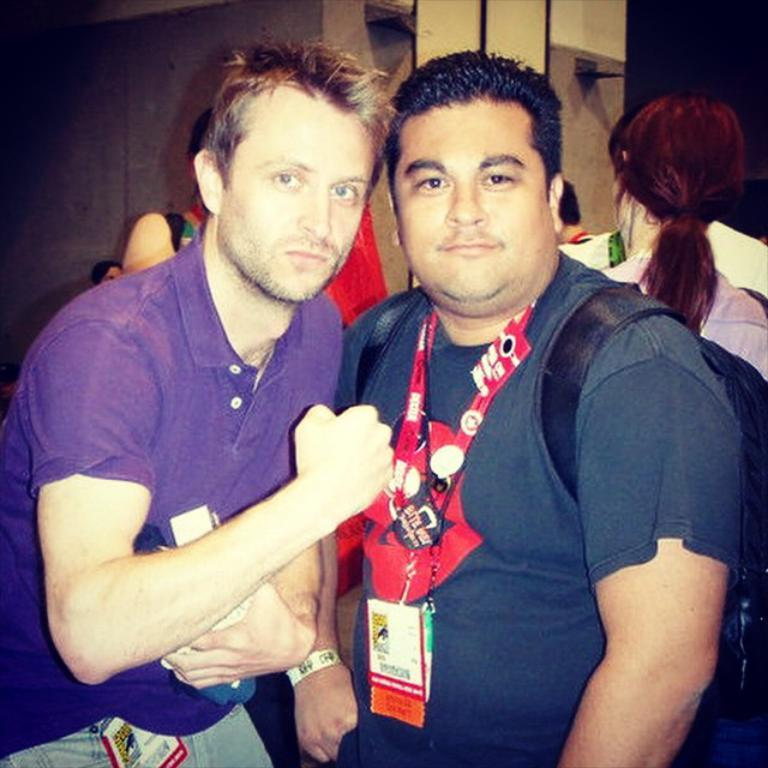How many people are present in the image? There are two persons in the image. What can be seen in the background of the image? There is a group of people and a wall in the background of the image. What type of sack is being used to carry the eggnog in the image? There is no eggnog or sack present in the image. What type of mine is visible in the background of the image? There is no mine visible in the image; it features two persons and a group of people in the background. 